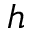<formula> <loc_0><loc_0><loc_500><loc_500>h</formula> 